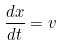<formula> <loc_0><loc_0><loc_500><loc_500>\frac { d x } { d t } = v</formula> 